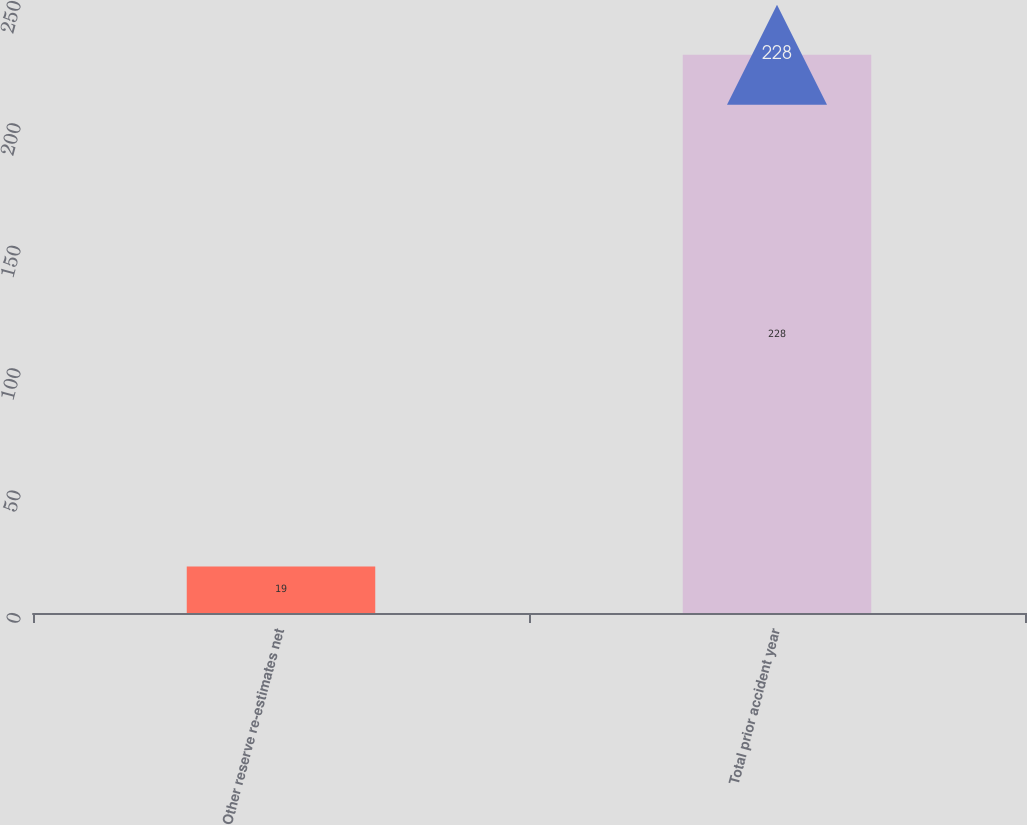Convert chart to OTSL. <chart><loc_0><loc_0><loc_500><loc_500><bar_chart><fcel>Other reserve re-estimates net<fcel>Total prior accident year<nl><fcel>19<fcel>228<nl></chart> 